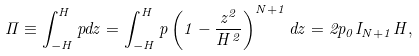Convert formula to latex. <formula><loc_0><loc_0><loc_500><loc_500>\Pi \equiv \int _ { - H } ^ { H } p d z = \int _ { - H } ^ { H } p \left ( 1 - \frac { z ^ { 2 } } { H ^ { 2 } } \right ) ^ { N + 1 } d z = 2 p _ { 0 } I _ { N + 1 } H ,</formula> 